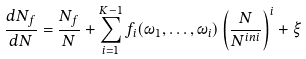Convert formula to latex. <formula><loc_0><loc_0><loc_500><loc_500>\frac { d N _ { f } } { d N } = \frac { N _ { f } } { N } + \sum _ { i = 1 } ^ { K - 1 } f _ { i } ( \omega _ { 1 } , \dots , \omega _ { i } ) \left ( \frac { N } { N ^ { i n i } } \right ) ^ { i } + \xi</formula> 